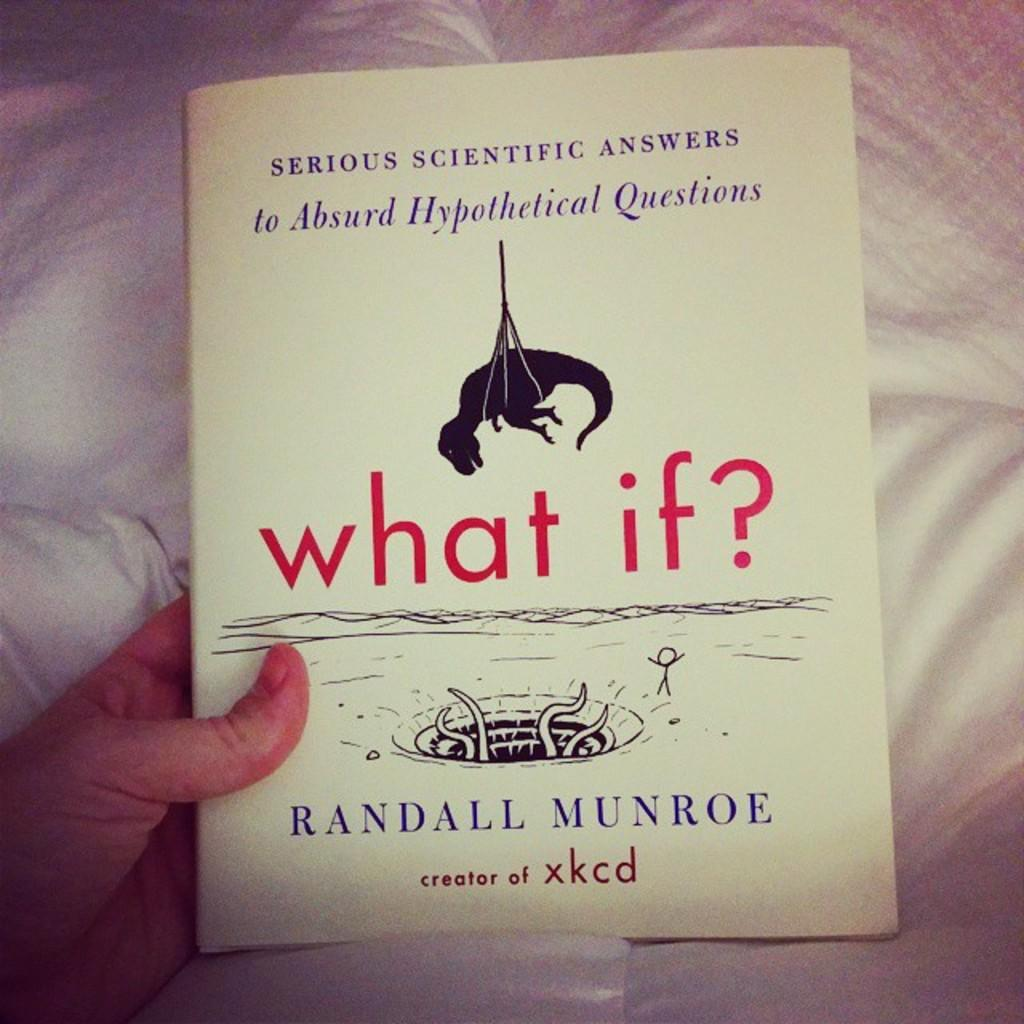Provide a one-sentence caption for the provided image. The book called What If by Randall Munroe is held by a person under a blanket. 